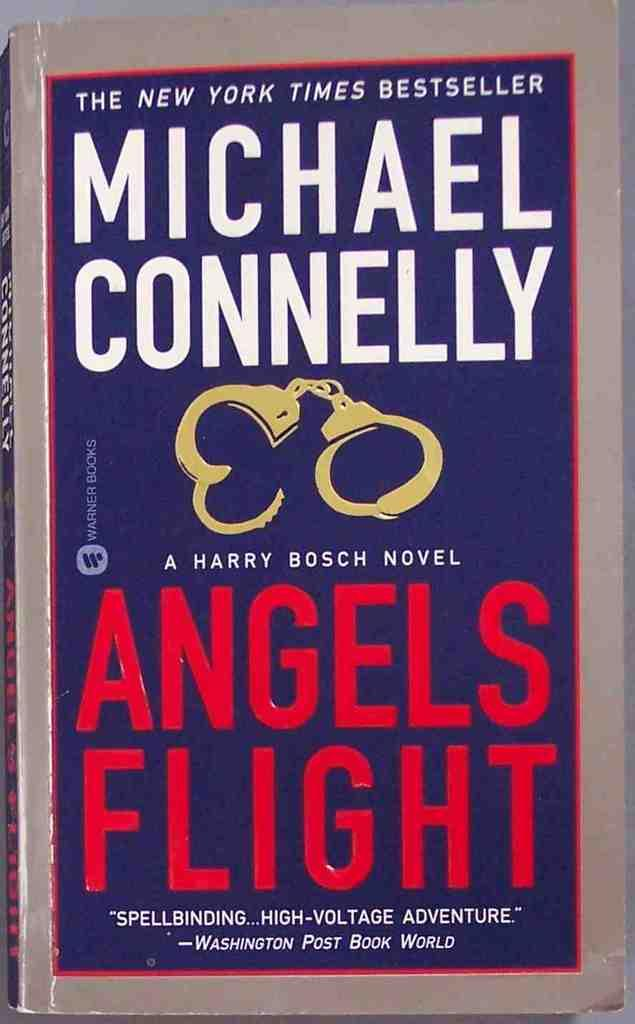<image>
Offer a succinct explanation of the picture presented. a book titled Angels Flight by Michael Connelly 